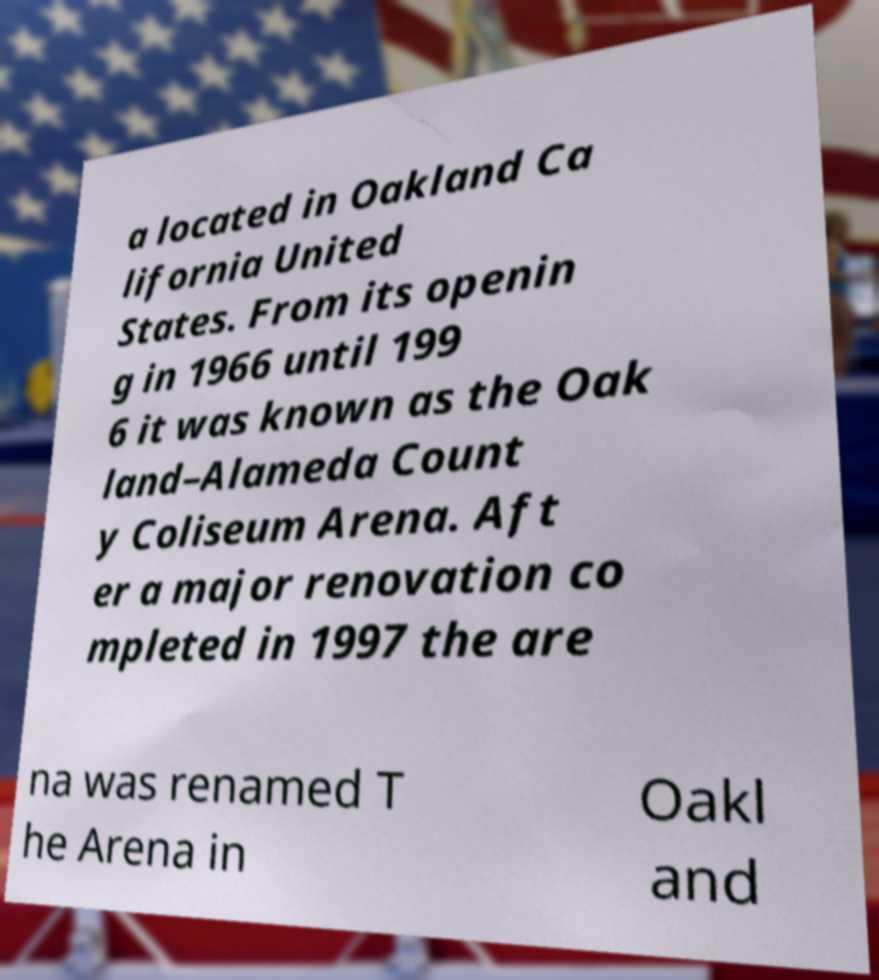Could you assist in decoding the text presented in this image and type it out clearly? a located in Oakland Ca lifornia United States. From its openin g in 1966 until 199 6 it was known as the Oak land–Alameda Count y Coliseum Arena. Aft er a major renovation co mpleted in 1997 the are na was renamed T he Arena in Oakl and 